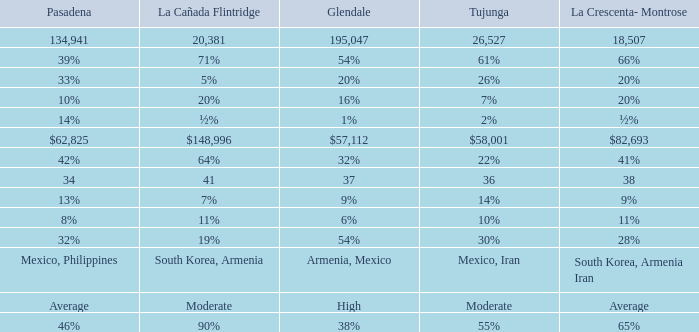What is the percentage of Tukunga when La Crescenta-Montrose is 28%? 30%. 